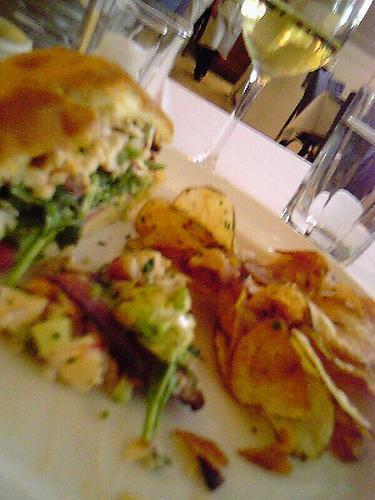How many sandwiches are there?
Give a very brief answer. 1. How many cups are there?
Give a very brief answer. 2. How many black umbrellas are on the walkway?
Give a very brief answer. 0. 